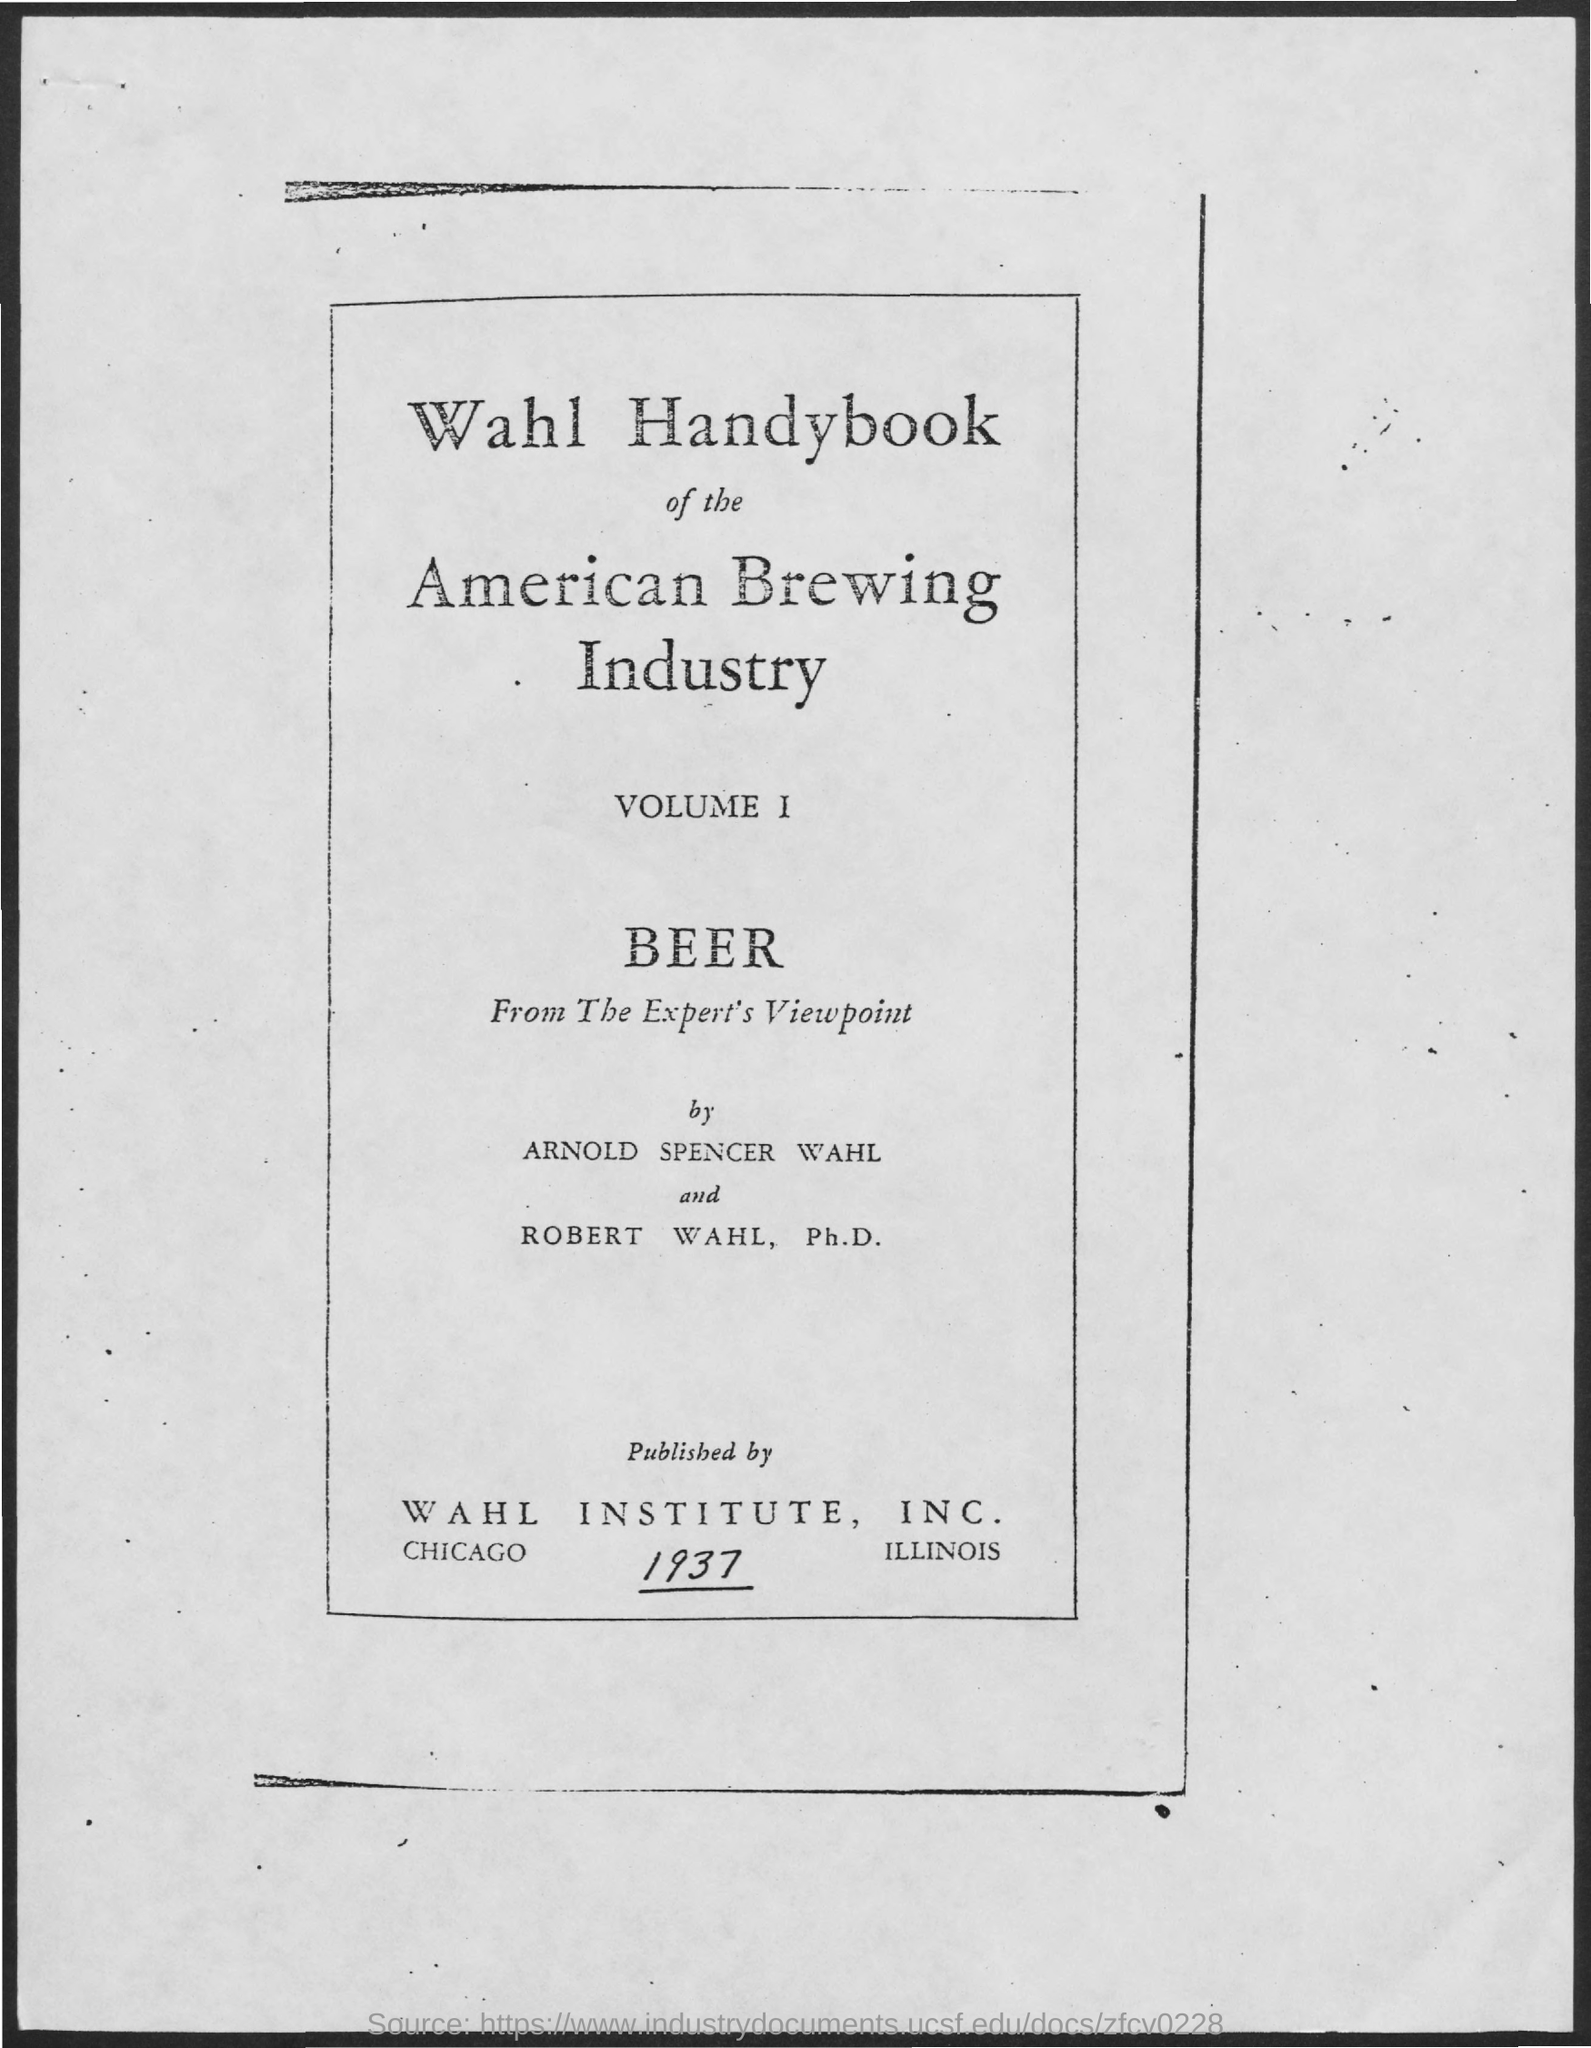Who are the authors of Wahl Handybook of the Ameican Brewing Industry?
Offer a terse response. Arnold spencer wahl and robert wahl, ph.d. Which company published the Wahl Handybook of the Ameican Brewing Industry?
Keep it short and to the point. WAHL INSTITUTE, INC. 